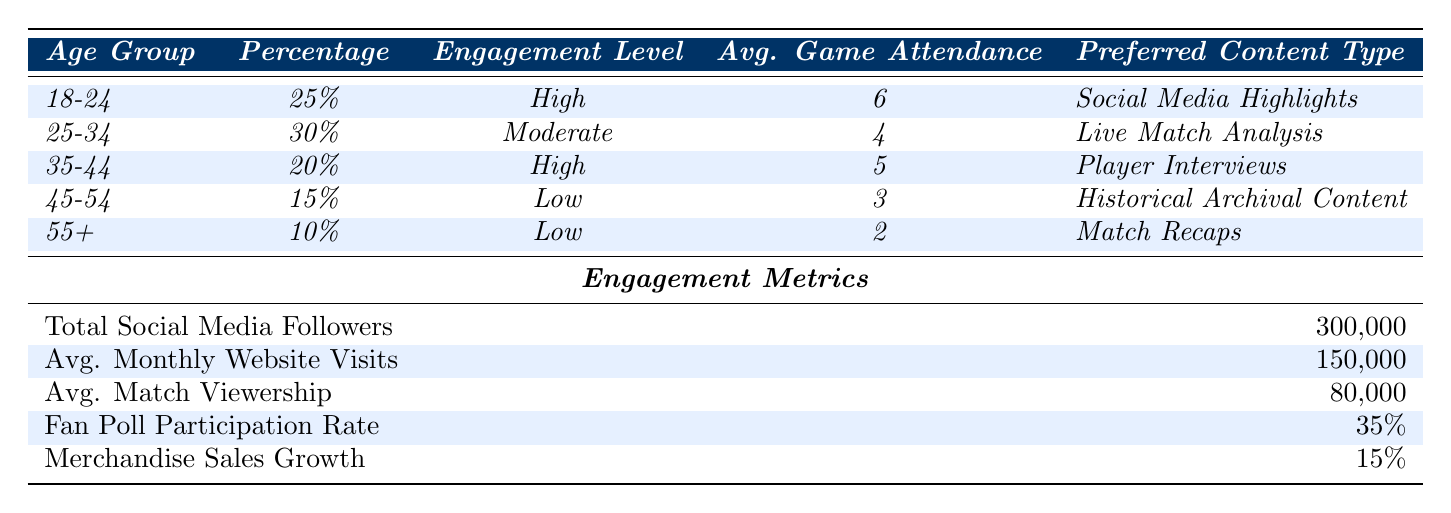What's the preferred content type for the 18-24 age group? The table states that the preferred content type for the 18-24 age group is "Social Media Highlights."
Answer: Social Media Highlights What is the average game attendance for fans aged 45-54? From the table, it shows that the average game attendance for the 45-54 age group is 3.
Answer: 3 Which age group has the highest engagement level? The age groups 18-24 and 35-44 both have a "High" engagement level, as noted in the table.
Answer: 18-24 and 35-44 What is the percentage of fans in the 25-34 age group? The table indicates that 30% of fans belong to the 25-34 age group.
Answer: 30% What is the total percentage of fans belonging to age groups with a low engagement level? The table shows that the 45-54 age group has 15% and the 55+ age group has 10%, summing these gives 15 + 10 = 25%.
Answer: 25% What content type is preferred by the age group with the lowest percentage of fans? The age group with the lowest percentage is 55+, which prefers "Match Recaps."
Answer: Match Recaps What is the average monthly website visits compared to average match viewership? The table shows 150,000 average monthly website visits and 80,000 average match viewership, so the website visits are greater.
Answer: Website visits are greater Does the average game attendance increase or decrease with age? Examining the average game attendance, it shows a decrease from 6 (18-24) to 2 (55+), indicating a decrease with age.
Answer: Decrease What percentage of total social media followers does the age group 35-44 represent? The table shows 20% in the 35-44 age group. The total followers are 300,000, so 20% of that is 60,000. Therefore, the participation representation needs deeper analysis for confirmation.
Answer: 60,000 (based on 20% of 300,000) What percentage of merchandise sales growth is recorded? The table indicates that merchandise sales growth is 15%.
Answer: 15% Which engagement metric has the highest value? Average monthly website visits of 150,000 is the highest engagement metric compared to others listed.
Answer: 150,000 What is the average game attendance for fans aged 25-34? According to the table, the average game attendance for the 25-34 age group is 4.
Answer: 4 